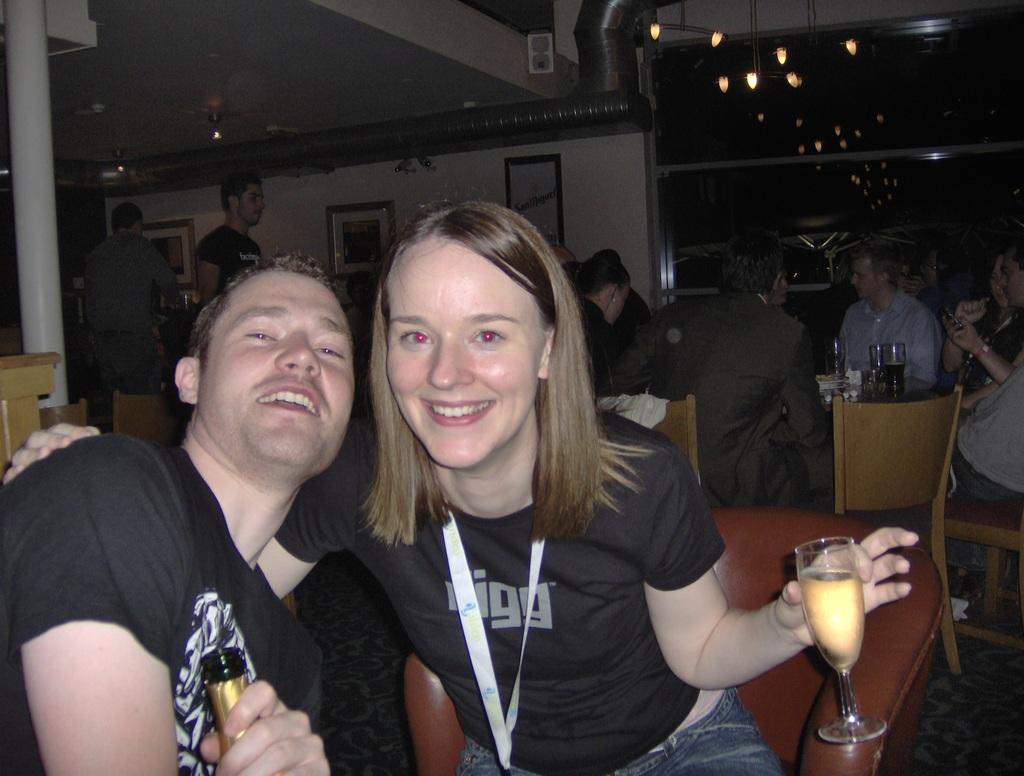What does the woman's shirt say?
Offer a terse response. Digg. 